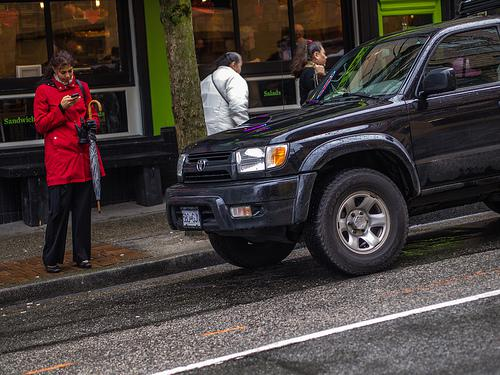Question: where was the photo taken?
Choices:
A. On the street.
B. Under signs.
C. Sidewalk.
D. Curb.
Answer with the letter. Answer: A Question: why is the photo clear?
Choices:
A. It's a good camera.
B. It's during the day.
C. It's focused.
D. The photographer is skilled.
Answer with the letter. Answer: B Question: what are the people wearing?
Choices:
A. Bathing suits.
B. Clothes.
C. Formal wear.
D. Costumes.
Answer with the letter. Answer: B Question: when was the photo taken?
Choices:
A. Daytime.
B. Dusk.
C. Early morning.
D. Night time.
Answer with the letter. Answer: A Question: who is in the photo?
Choices:
A. People.
B. Animals.
C. No one.
D. Schoolchildren.
Answer with the letter. Answer: A 